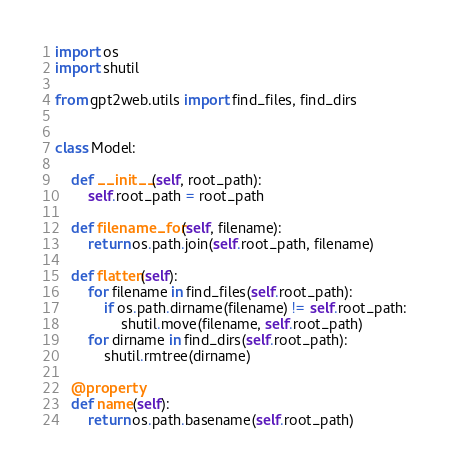<code> <loc_0><loc_0><loc_500><loc_500><_Python_>import os
import shutil

from gpt2web.utils import find_files, find_dirs


class Model:

    def __init__(self, root_path):
        self.root_path = root_path

    def filename_for(self, filename):
        return os.path.join(self.root_path, filename)

    def flatten(self):
        for filename in find_files(self.root_path):
            if os.path.dirname(filename) != self.root_path:
                shutil.move(filename, self.root_path)
        for dirname in find_dirs(self.root_path):
            shutil.rmtree(dirname)

    @property
    def name(self):
        return os.path.basename(self.root_path)
</code> 